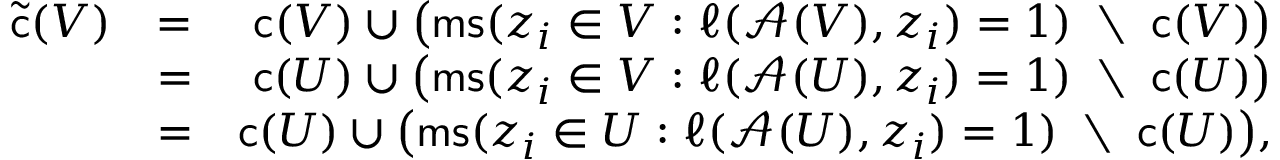<formula> <loc_0><loc_0><loc_500><loc_500>\begin{array} { r l r } { \tilde { c } ( V ) } & { = } & { c ( V ) \cup \left ( m s ( z _ { i } \in V \colon \ell ( \mathcal { A } ( V ) , z _ { i } ) = 1 ) \, \ \, c ( V ) \right ) } \\ & { = } & { c ( U ) \cup \left ( m s ( z _ { i } \in V \colon \ell ( \mathcal { A } ( U ) , z _ { i } ) = 1 ) \, \ \, c ( U ) \right ) } \\ & { = } & { c ( U ) \cup \left ( m s ( z _ { i } \in U \colon \ell ( \mathcal { A } ( U ) , z _ { i } ) = 1 ) \, \ \, c ( U ) \right ) , } \end{array}</formula> 